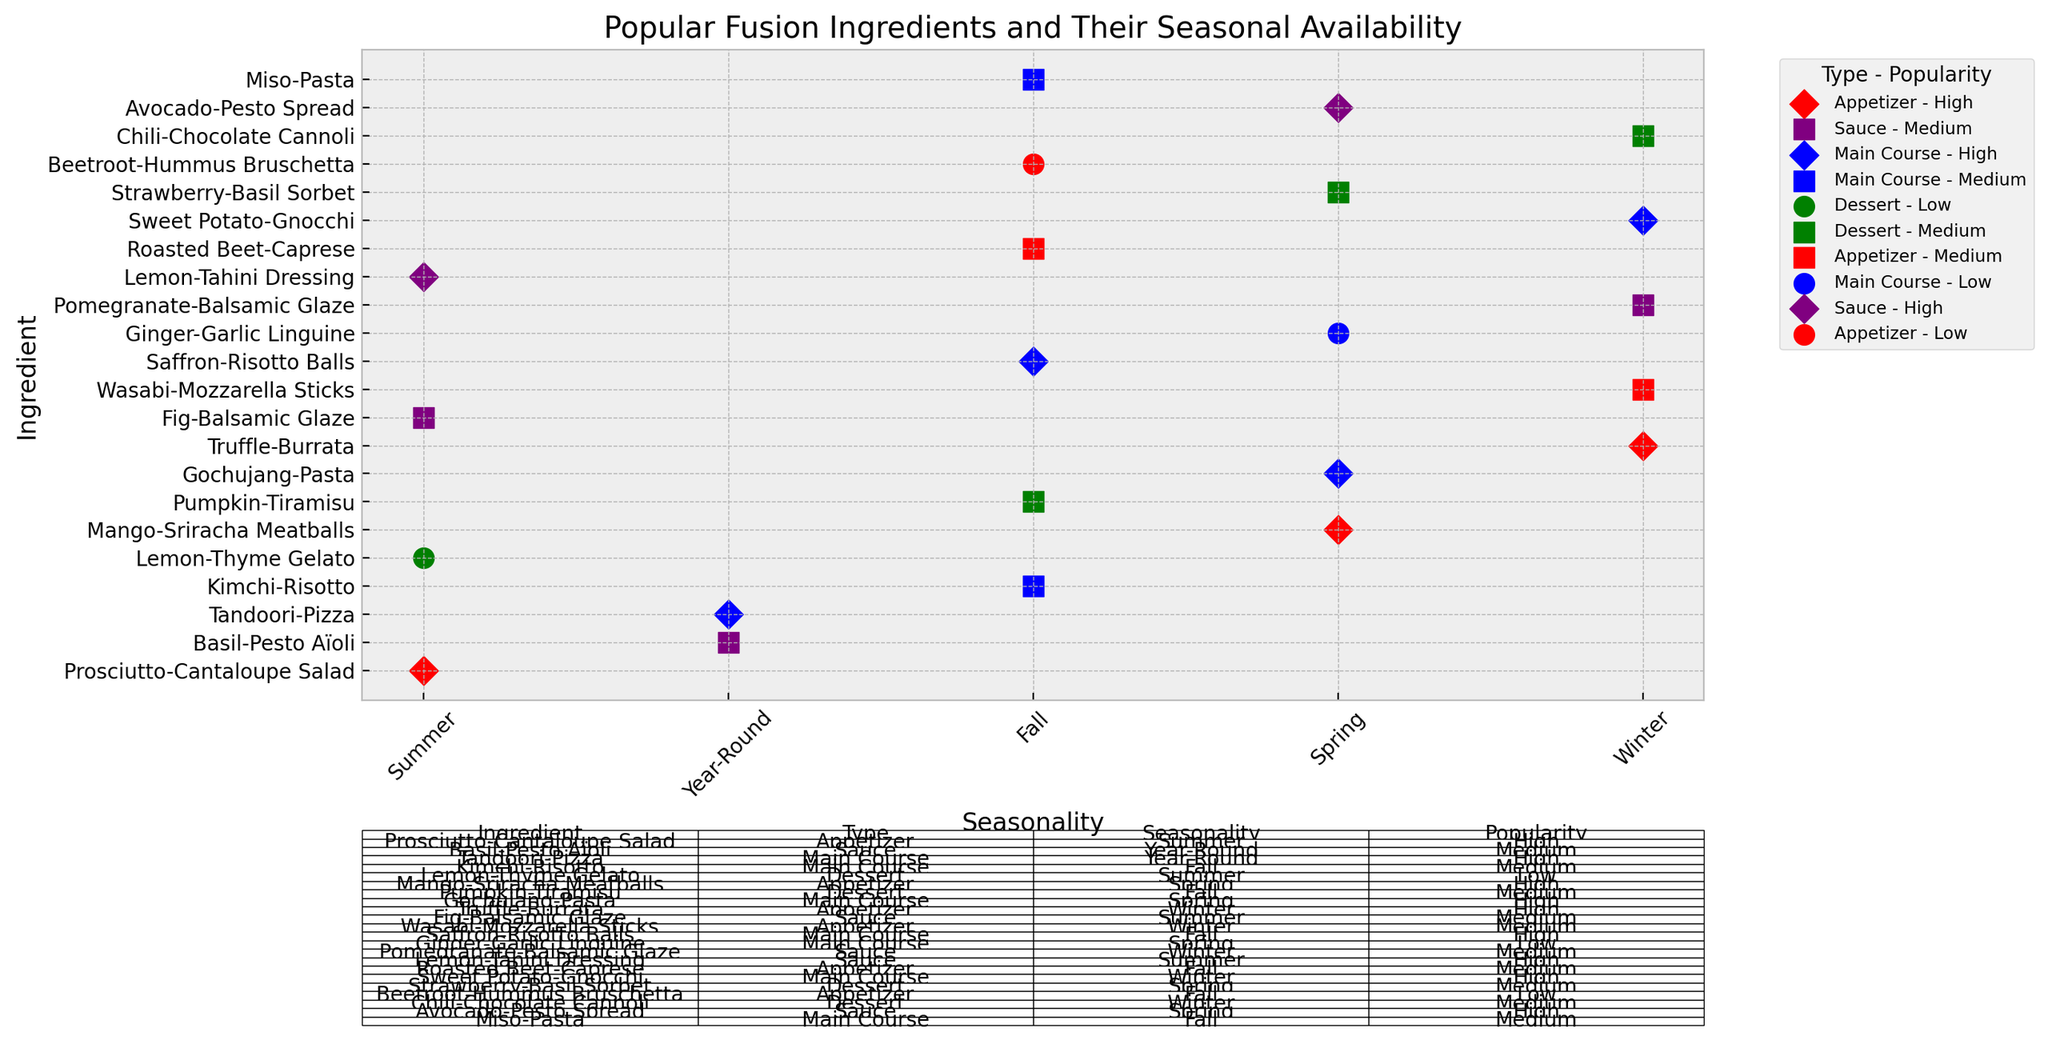How many main course ingredients are listed on the chart? The color blue represents main course ingredients. By counting the blue markers on the chart, we determine that there are 7 main course ingredients.
Answer: 7 Which appetizer ingredient is available in the summer and has high popularity? The red markers represent appetizers. By looking for a red marker in the "Summer" column with a diamond shape (high popularity), we find Prosciutto-Cantaloupe Salad.
Answer: Prosciutto-Cantaloupe Salad Which dessert ingredient is available in the winter season? The green markers represent desserts. By looking for green markers in the "Winter" column, we find Chili-Chocolate Cannoli.
Answer: Chili-Chocolate Cannoli Which ingredient types can be found year-round? By checking the "Year-Round" column and noting the ingredient types, we find 'Sauce' and 'Main Course'.
Answer: Sauce, Main Course How many ingredients are available in the spring season? By counting the markers in the "Spring" column across all ingredient types, we find there are 5 ingredients available in spring.
Answer: 5 Which ingredient has the highest popularity and is available in the fall season? By looking at the markers for the "Fall" season, and identifying the diamond-shaped markers (high popularity), we determine Saffron-Risotto Balls as the main course ingredient with highest popularity.
Answer: Saffron-Risotto Balls Compare the popularity of sauces and appetizers in the winter season. Which type has higher average popularity? First, identify the winter season's sauces and appetizers. Sauces: Pomegranate-Balsamic Glaze (medium). Appetizers: Truffle-Burrata (high), Wasabi-Mozzarella Sticks (medium). Average popularity for sauces is medium (1 medium). Average popularity for appetizers is between high and medium (1 high, 1 medium). Therefore, appetizers have higher average popularity.
Answer: Appetizers Is there more variety in the ingredients for summer or winter season? Count the number of unique ingredients in the summer and winter seasons. Summer has 4 ingredients (Prosciutto-Cantaloupe Salad, Lemon-Thyme Gelato, Fig-Balsamic Glaze, Lemon-Tahini Dressing) and Winter has 4 ingredients (Truffle-Burrata, Wasabi-Mozzarella Sticks, Pomegranate-Balsamic Glaze, Chili-Chocolate Cannoli). Both have equal variety.
Answer: Both What is the most popular ingredient type in the spring season? By identifying the shapes in the "Spring" column: Gochujang-Pasta (Main Course), Mango-Sriracha Meatballs (Appetizer), Avocado-Pesto Spread (Sauce), Ginger-Garlic Linguine (Main Course), Strawberry-Basil Sorbet (Dessert). The most popular type (with highest popularity markers) in spring is Appetizer and Sauce.
Answer: Appetizer, Sauce Among sauces available year-round, which ones have medium popularity? By checking the "Year-Round" column and looking at the purple square markers (medium popularity), we find Basil-Pesto Aïoli.
Answer: Basil-Pesto Aïoli 